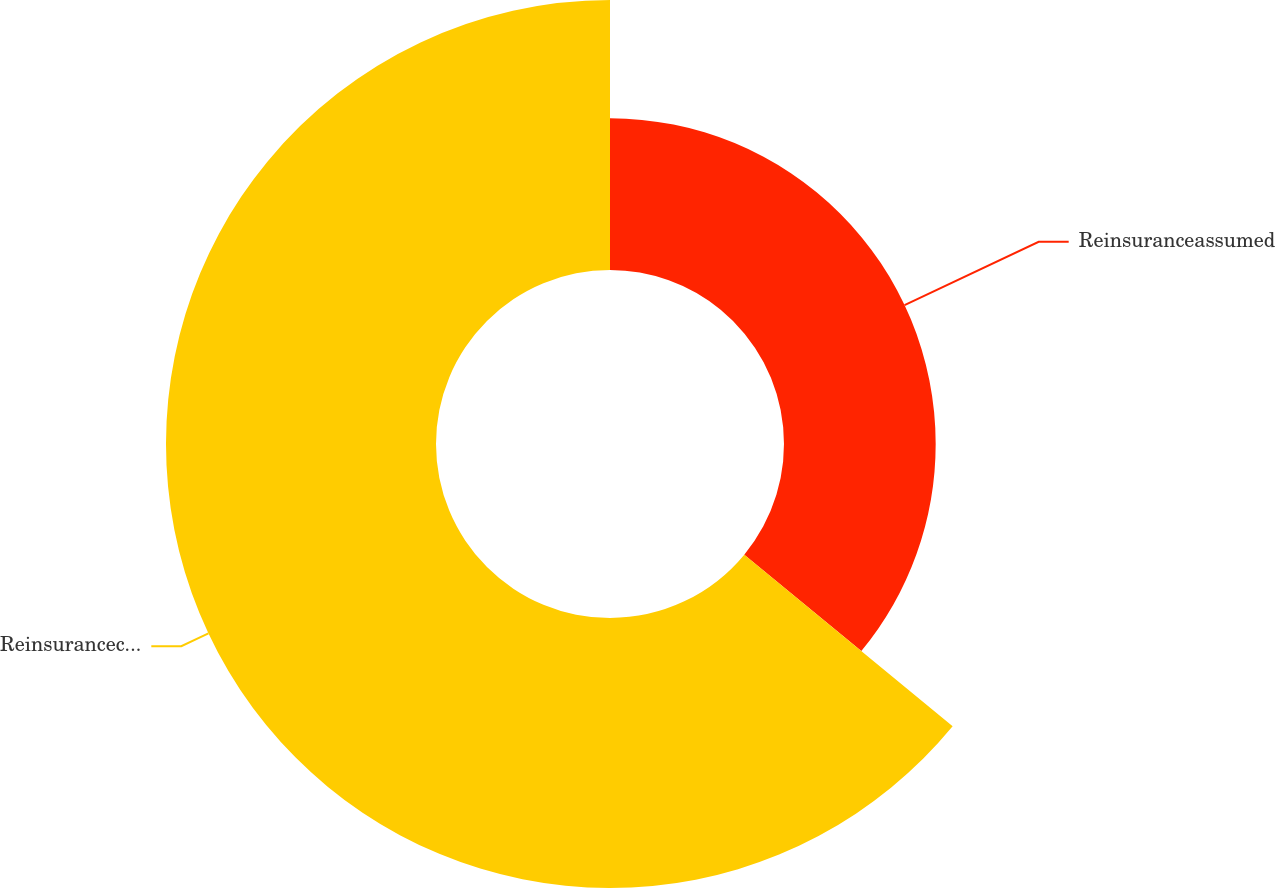<chart> <loc_0><loc_0><loc_500><loc_500><pie_chart><fcel>Reinsuranceassumed<fcel>Reinsuranceceded<nl><fcel>35.97%<fcel>64.03%<nl></chart> 